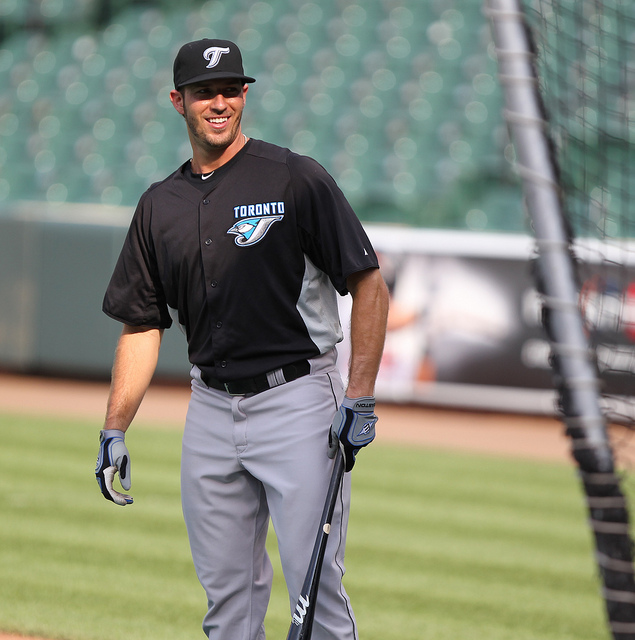Please transcribe the text information in this image. TORONTO m T 